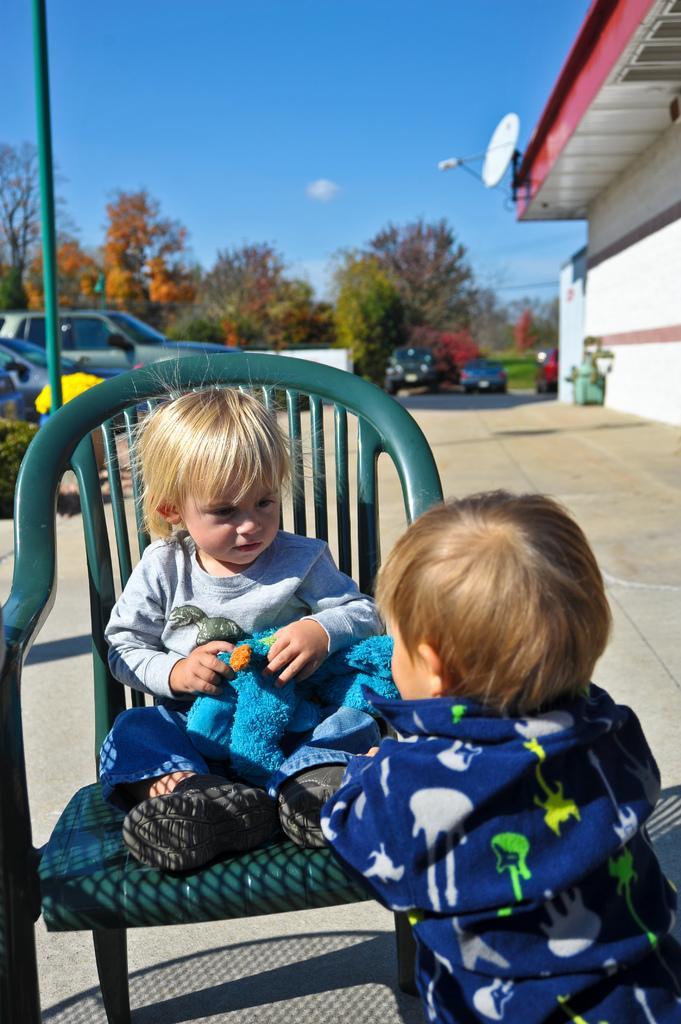Can you describe this image briefly? To the left side of the image there is a green chair. On the chair there is a kid with grey t-shirt, blue pant and black shoes is sitting on the chair. In front of the chair to the right side there is a kid with blue shirt is standing. To the left corner of the image behind the chair there is a pole. Behind the pole there are few vehicles. And in the background there are trees and also there are two cars. To the right corner of the image there is a white building with a dish TV antenna on it. And to the top of the image there is a sky. 